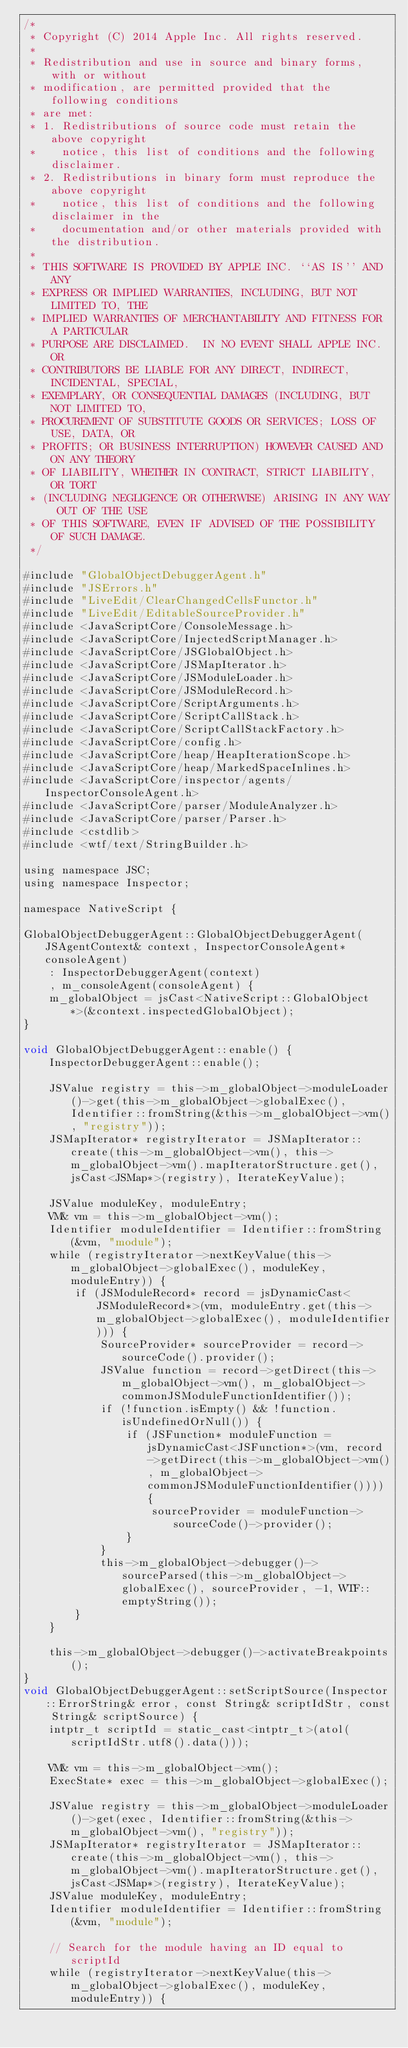Convert code to text. <code><loc_0><loc_0><loc_500><loc_500><_ObjectiveC_>/*
 * Copyright (C) 2014 Apple Inc. All rights reserved.
 *
 * Redistribution and use in source and binary forms, with or without
 * modification, are permitted provided that the following conditions
 * are met:
 * 1. Redistributions of source code must retain the above copyright
 *    notice, this list of conditions and the following disclaimer.
 * 2. Redistributions in binary form must reproduce the above copyright
 *    notice, this list of conditions and the following disclaimer in the
 *    documentation and/or other materials provided with the distribution.
 *
 * THIS SOFTWARE IS PROVIDED BY APPLE INC. ``AS IS'' AND ANY
 * EXPRESS OR IMPLIED WARRANTIES, INCLUDING, BUT NOT LIMITED TO, THE
 * IMPLIED WARRANTIES OF MERCHANTABILITY AND FITNESS FOR A PARTICULAR
 * PURPOSE ARE DISCLAIMED.  IN NO EVENT SHALL APPLE INC. OR
 * CONTRIBUTORS BE LIABLE FOR ANY DIRECT, INDIRECT, INCIDENTAL, SPECIAL,
 * EXEMPLARY, OR CONSEQUENTIAL DAMAGES (INCLUDING, BUT NOT LIMITED TO,
 * PROCUREMENT OF SUBSTITUTE GOODS OR SERVICES; LOSS OF USE, DATA, OR
 * PROFITS; OR BUSINESS INTERRUPTION) HOWEVER CAUSED AND ON ANY THEORY
 * OF LIABILITY, WHETHER IN CONTRACT, STRICT LIABILITY, OR TORT
 * (INCLUDING NEGLIGENCE OR OTHERWISE) ARISING IN ANY WAY OUT OF THE USE
 * OF THIS SOFTWARE, EVEN IF ADVISED OF THE POSSIBILITY OF SUCH DAMAGE.
 */

#include "GlobalObjectDebuggerAgent.h"
#include "JSErrors.h"
#include "LiveEdit/ClearChangedCellsFunctor.h"
#include "LiveEdit/EditableSourceProvider.h"
#include <JavaScriptCore/ConsoleMessage.h>
#include <JavaScriptCore/InjectedScriptManager.h>
#include <JavaScriptCore/JSGlobalObject.h>
#include <JavaScriptCore/JSMapIterator.h>
#include <JavaScriptCore/JSModuleLoader.h>
#include <JavaScriptCore/JSModuleRecord.h>
#include <JavaScriptCore/ScriptArguments.h>
#include <JavaScriptCore/ScriptCallStack.h>
#include <JavaScriptCore/ScriptCallStackFactory.h>
#include <JavaScriptCore/config.h>
#include <JavaScriptCore/heap/HeapIterationScope.h>
#include <JavaScriptCore/heap/MarkedSpaceInlines.h>
#include <JavaScriptCore/inspector/agents/InspectorConsoleAgent.h>
#include <JavaScriptCore/parser/ModuleAnalyzer.h>
#include <JavaScriptCore/parser/Parser.h>
#include <cstdlib>
#include <wtf/text/StringBuilder.h>

using namespace JSC;
using namespace Inspector;

namespace NativeScript {

GlobalObjectDebuggerAgent::GlobalObjectDebuggerAgent(JSAgentContext& context, InspectorConsoleAgent* consoleAgent)
    : InspectorDebuggerAgent(context)
    , m_consoleAgent(consoleAgent) {
    m_globalObject = jsCast<NativeScript::GlobalObject*>(&context.inspectedGlobalObject);
}

void GlobalObjectDebuggerAgent::enable() {
    InspectorDebuggerAgent::enable();

    JSValue registry = this->m_globalObject->moduleLoader()->get(this->m_globalObject->globalExec(), Identifier::fromString(&this->m_globalObject->vm(), "registry"));
    JSMapIterator* registryIterator = JSMapIterator::create(this->m_globalObject->vm(), this->m_globalObject->vm().mapIteratorStructure.get(), jsCast<JSMap*>(registry), IterateKeyValue);

    JSValue moduleKey, moduleEntry;
    VM& vm = this->m_globalObject->vm();
    Identifier moduleIdentifier = Identifier::fromString(&vm, "module");
    while (registryIterator->nextKeyValue(this->m_globalObject->globalExec(), moduleKey, moduleEntry)) {
        if (JSModuleRecord* record = jsDynamicCast<JSModuleRecord*>(vm, moduleEntry.get(this->m_globalObject->globalExec(), moduleIdentifier))) {
            SourceProvider* sourceProvider = record->sourceCode().provider();
            JSValue function = record->getDirect(this->m_globalObject->vm(), m_globalObject->commonJSModuleFunctionIdentifier());
            if (!function.isEmpty() && !function.isUndefinedOrNull()) {
                if (JSFunction* moduleFunction = jsDynamicCast<JSFunction*>(vm, record->getDirect(this->m_globalObject->vm(), m_globalObject->commonJSModuleFunctionIdentifier()))) {
                    sourceProvider = moduleFunction->sourceCode()->provider();
                }
            }
            this->m_globalObject->debugger()->sourceParsed(this->m_globalObject->globalExec(), sourceProvider, -1, WTF::emptyString());
        }
    }

    this->m_globalObject->debugger()->activateBreakpoints();
}
void GlobalObjectDebuggerAgent::setScriptSource(Inspector::ErrorString& error, const String& scriptIdStr, const String& scriptSource) {
    intptr_t scriptId = static_cast<intptr_t>(atol(scriptIdStr.utf8().data()));

    VM& vm = this->m_globalObject->vm();
    ExecState* exec = this->m_globalObject->globalExec();

    JSValue registry = this->m_globalObject->moduleLoader()->get(exec, Identifier::fromString(&this->m_globalObject->vm(), "registry"));
    JSMapIterator* registryIterator = JSMapIterator::create(this->m_globalObject->vm(), this->m_globalObject->vm().mapIteratorStructure.get(), jsCast<JSMap*>(registry), IterateKeyValue);
    JSValue moduleKey, moduleEntry;
    Identifier moduleIdentifier = Identifier::fromString(&vm, "module");

    // Search for the module having an ID equal to scriptId
    while (registryIterator->nextKeyValue(this->m_globalObject->globalExec(), moduleKey, moduleEntry)) {</code> 